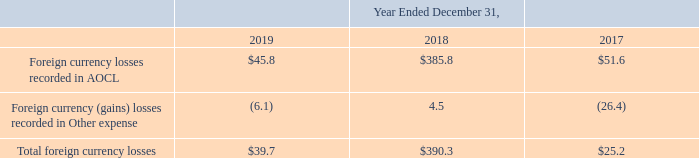AMERICAN TOWER CORPORATION AND SUBSIDIARIES NOTES TO CONSOLIDATED FINANCIAL STATEMENTS (Tabular amounts in millions, unless otherwise disclosed) net foreign currency losses
(“AOCL”) in the consolidated balance sheets and included as a component of Comprehensive income in the consolidated
statements of comprehensive income.
Gains and losses on foreign currency transactions are reflected in Other expense in the consolidated statements of operations. However, the effect from fluctuations in foreign currency exchange rates on intercompany debt for which repayment is not anticipated in the foreseeable future is reflected in AOCL in the consolidated balance sheets and included as a component of Comprehensive income.
The Company recorded the following net foreign currency losses:
What were the Foreign currency losses recorded in AOCL in 2019?
Answer scale should be: million. $45.8. What were the Foreign currency (gains) losses recorded in Other expense in 2018?
Answer scale should be: million. 4.5. What does the table show? Net foreign currency losses. What was the change in Foreign currency losses recorded in AOCL between 2018 and 2019?
Answer scale should be: million. $45.8-$385.8
Answer: -340. What was the change in Foreign currency (gains) losses recorded in Other expense between 2017 and 2018?
Answer scale should be: million. 4.5-(-26.4)
Answer: 30.9. What was the total percentage change in Total foreign currency losses between 2017 and 2019?
Answer scale should be: percent. ($39.7-$25.2)/$25.2
Answer: 57.54. 